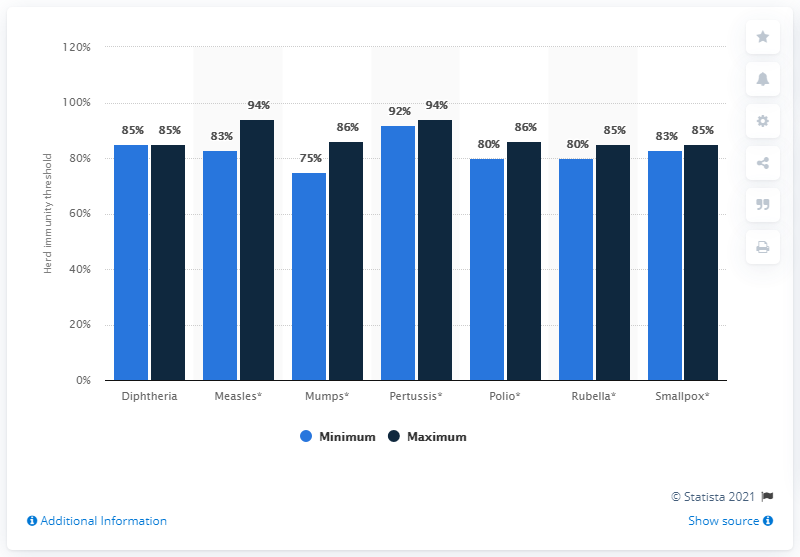Highlight a few significant elements in this photo. The maximum threshold for herd immunity against mumps as of 2013 was 86%. The maximum and minimum threshold for herd immunity for smallpox as of 2013 were 80% and 64%, respectively. 